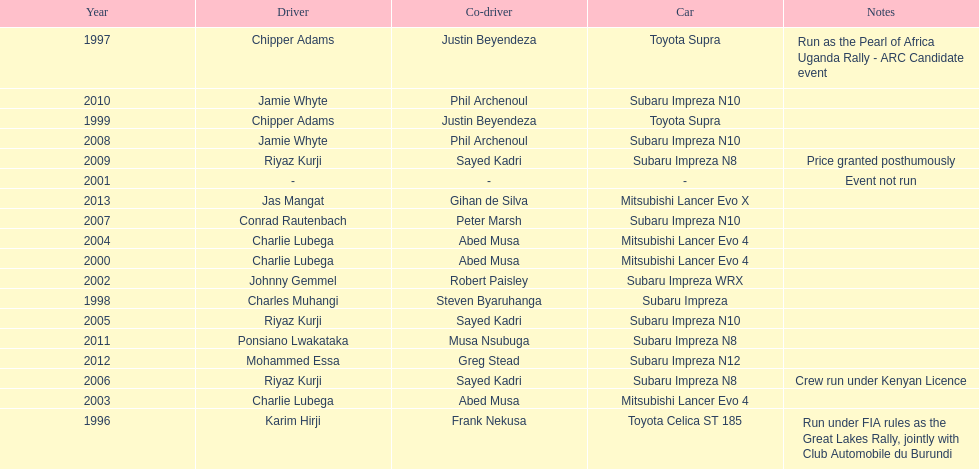What is the total number of times that the winning driver was driving a toyota supra? 2. 